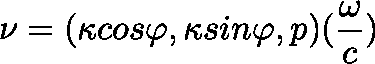Convert formula to latex. <formula><loc_0><loc_0><loc_500><loc_500>\nu = ( { \kappa } \cos { \varphi } , { \kappa } \sin { \varphi } , p ) ( \frac { \omega } { c } )</formula> 